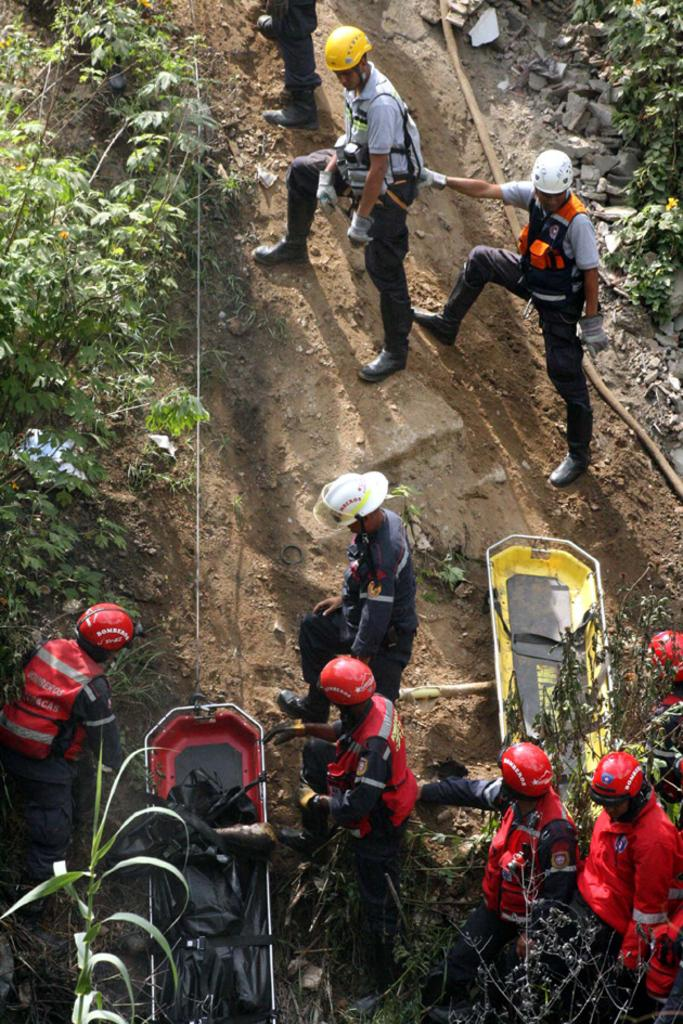How many people are in the image? There are many people in the image. What are the people wearing? The people are wearing jackets. What activity are the people engaged in? The people are trekking. What can be seen on the left side of the image? There are plants on the left side of the image. Can you see any deer interacting with the people in the image? There are no deer present in the image. What type of paste is being used by the people while trekking? There is no mention of paste in the image or the provided facts. 